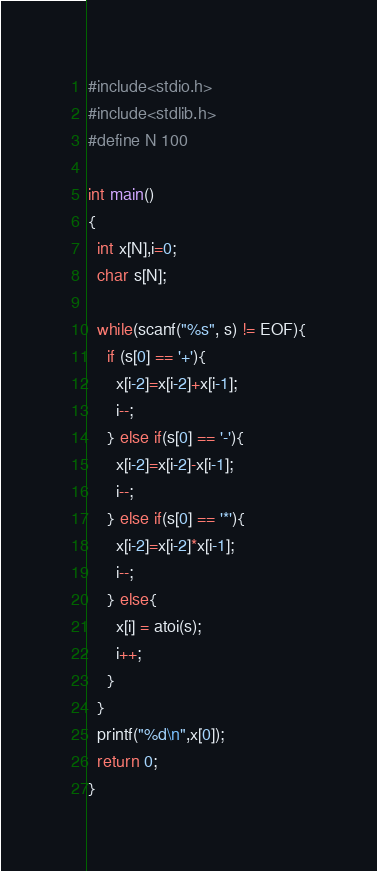<code> <loc_0><loc_0><loc_500><loc_500><_C_>#include<stdio.h>
#include<stdlib.h>
#define N 100
 
int main()
{
  int x[N],i=0;
  char s[N];
 
  while(scanf("%s", s) != EOF){
    if (s[0] == '+'){
      x[i-2]=x[i-2]+x[i-1];
      i--; 
    } else if(s[0] == '-'){
      x[i-2]=x[i-2]-x[i-1];
      i--;
    } else if(s[0] == '*'){
      x[i-2]=x[i-2]*x[i-1];
      i--;
    } else{
      x[i] = atoi(s);
      i++;
    }
  }
  printf("%d\n",x[0]);
  return 0;
}</code> 